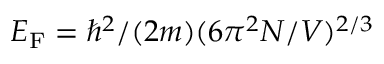<formula> <loc_0><loc_0><loc_500><loc_500>E _ { F } = \hbar { ^ } { 2 } / ( 2 m ) ( 6 \pi ^ { 2 } N / V ) ^ { 2 / 3 }</formula> 